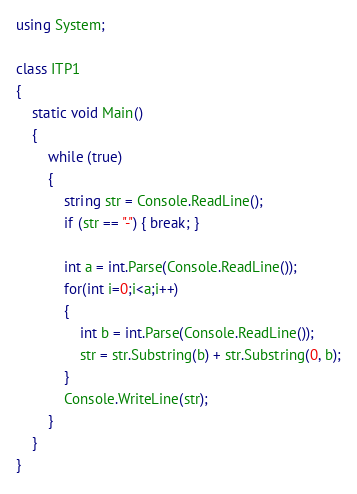Convert code to text. <code><loc_0><loc_0><loc_500><loc_500><_C#_>using System;

class ITP1
{
    static void Main()
    {
        while (true)
        {
            string str = Console.ReadLine();
            if (str == "-") { break; }

            int a = int.Parse(Console.ReadLine());
            for(int i=0;i<a;i++)
            {
                int b = int.Parse(Console.ReadLine());
                str = str.Substring(b) + str.Substring(0, b);
            }
            Console.WriteLine(str);
        }
    }
}</code> 